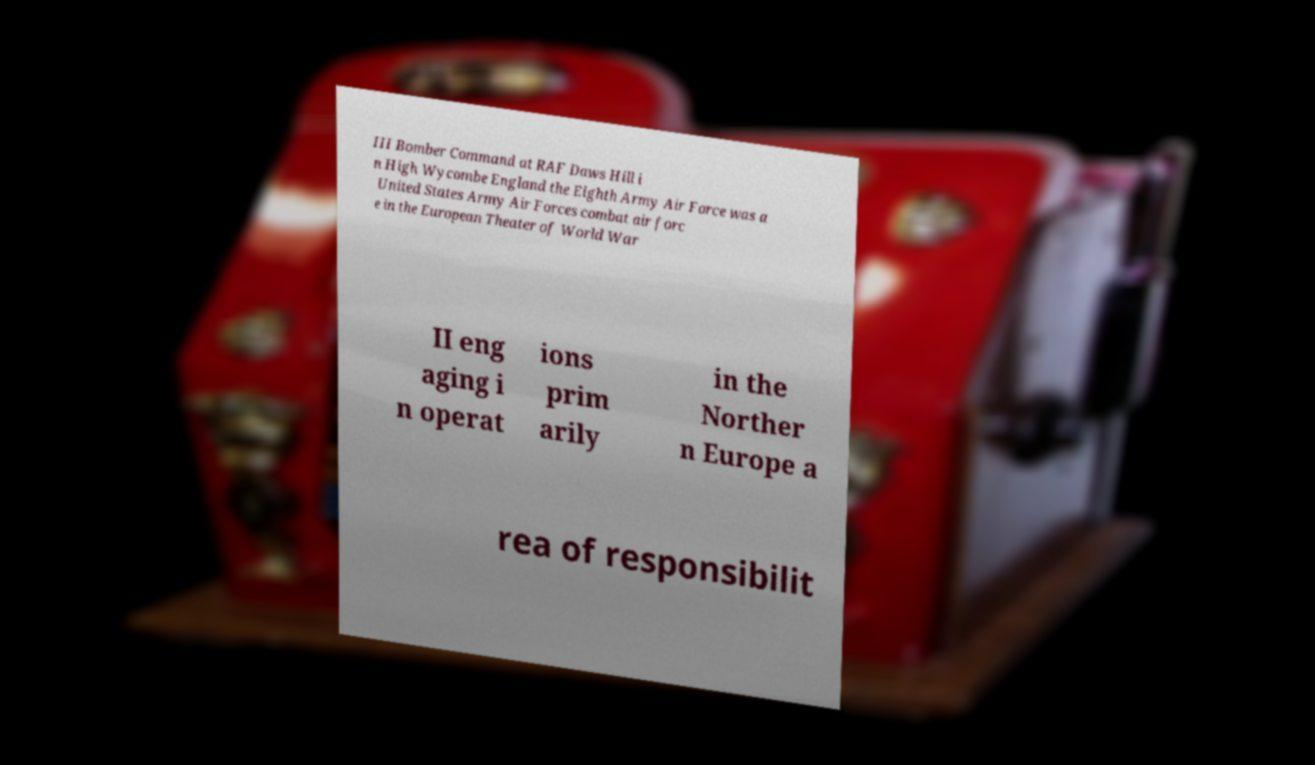What messages or text are displayed in this image? I need them in a readable, typed format. III Bomber Command at RAF Daws Hill i n High Wycombe England the Eighth Army Air Force was a United States Army Air Forces combat air forc e in the European Theater of World War II eng aging i n operat ions prim arily in the Norther n Europe a rea of responsibilit 